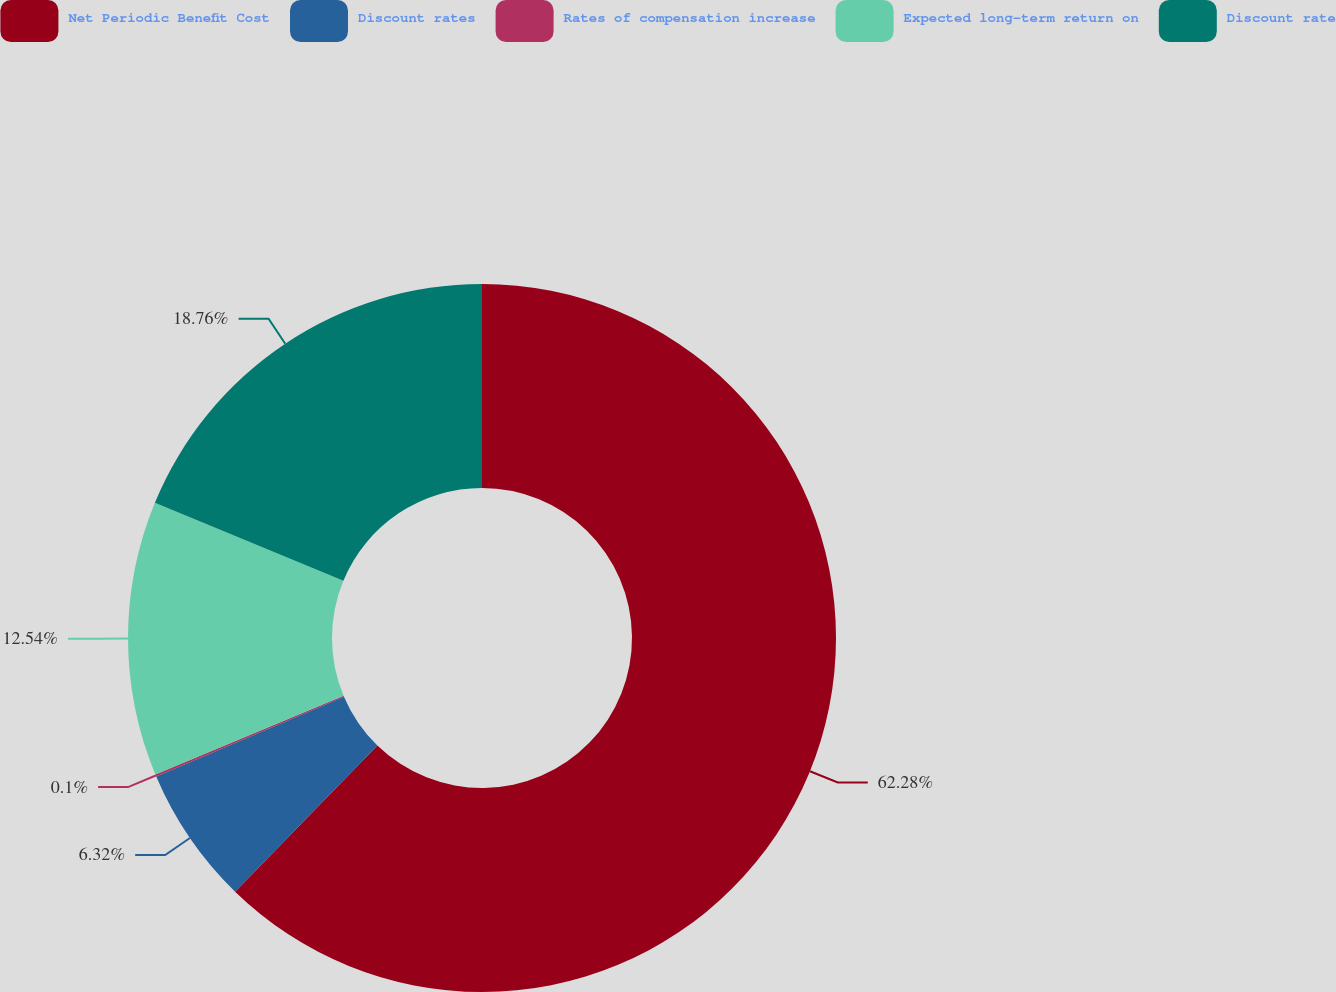Convert chart to OTSL. <chart><loc_0><loc_0><loc_500><loc_500><pie_chart><fcel>Net Periodic Benefit Cost<fcel>Discount rates<fcel>Rates of compensation increase<fcel>Expected long-term return on<fcel>Discount rate<nl><fcel>62.29%<fcel>6.32%<fcel>0.1%<fcel>12.54%<fcel>18.76%<nl></chart> 